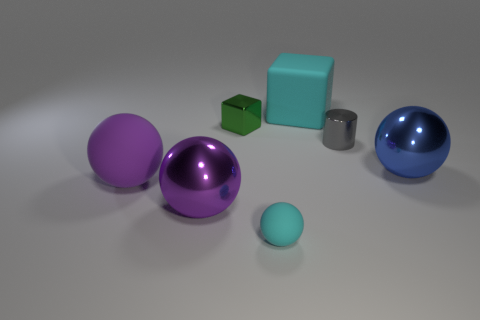Add 3 purple things. How many objects exist? 10 Subtract all red balls. Subtract all green blocks. How many balls are left? 4 Subtract all blocks. How many objects are left? 5 Subtract all big green metallic spheres. Subtract all green objects. How many objects are left? 6 Add 7 green things. How many green things are left? 8 Add 2 small blue matte blocks. How many small blue matte blocks exist? 2 Subtract 0 red blocks. How many objects are left? 7 